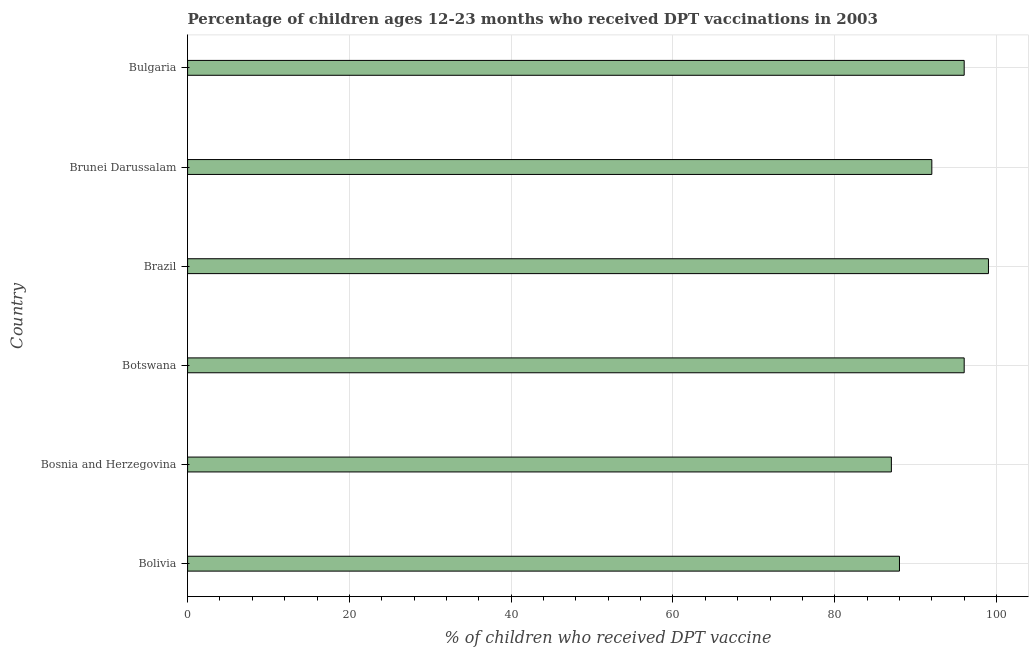What is the title of the graph?
Your answer should be very brief. Percentage of children ages 12-23 months who received DPT vaccinations in 2003. What is the label or title of the X-axis?
Ensure brevity in your answer.  % of children who received DPT vaccine. What is the percentage of children who received dpt vaccine in Botswana?
Your answer should be very brief. 96. In which country was the percentage of children who received dpt vaccine maximum?
Provide a succinct answer. Brazil. In which country was the percentage of children who received dpt vaccine minimum?
Give a very brief answer. Bosnia and Herzegovina. What is the sum of the percentage of children who received dpt vaccine?
Provide a succinct answer. 558. What is the difference between the percentage of children who received dpt vaccine in Bolivia and Botswana?
Keep it short and to the point. -8. What is the average percentage of children who received dpt vaccine per country?
Keep it short and to the point. 93. What is the median percentage of children who received dpt vaccine?
Ensure brevity in your answer.  94. What is the ratio of the percentage of children who received dpt vaccine in Bosnia and Herzegovina to that in Bulgaria?
Your answer should be compact. 0.91. Is the percentage of children who received dpt vaccine in Bolivia less than that in Brazil?
Offer a terse response. Yes. What is the difference between the highest and the second highest percentage of children who received dpt vaccine?
Offer a very short reply. 3. What is the difference between the highest and the lowest percentage of children who received dpt vaccine?
Make the answer very short. 12. In how many countries, is the percentage of children who received dpt vaccine greater than the average percentage of children who received dpt vaccine taken over all countries?
Keep it short and to the point. 3. Are all the bars in the graph horizontal?
Make the answer very short. Yes. How many countries are there in the graph?
Your response must be concise. 6. What is the % of children who received DPT vaccine in Botswana?
Keep it short and to the point. 96. What is the % of children who received DPT vaccine in Brazil?
Offer a terse response. 99. What is the % of children who received DPT vaccine in Brunei Darussalam?
Offer a terse response. 92. What is the % of children who received DPT vaccine of Bulgaria?
Offer a very short reply. 96. What is the difference between the % of children who received DPT vaccine in Bolivia and Bosnia and Herzegovina?
Your response must be concise. 1. What is the difference between the % of children who received DPT vaccine in Bolivia and Brazil?
Your response must be concise. -11. What is the difference between the % of children who received DPT vaccine in Bolivia and Brunei Darussalam?
Keep it short and to the point. -4. What is the difference between the % of children who received DPT vaccine in Bolivia and Bulgaria?
Make the answer very short. -8. What is the difference between the % of children who received DPT vaccine in Bosnia and Herzegovina and Botswana?
Offer a terse response. -9. What is the difference between the % of children who received DPT vaccine in Bosnia and Herzegovina and Brazil?
Ensure brevity in your answer.  -12. What is the difference between the % of children who received DPT vaccine in Bosnia and Herzegovina and Bulgaria?
Provide a succinct answer. -9. What is the difference between the % of children who received DPT vaccine in Botswana and Brazil?
Offer a terse response. -3. What is the difference between the % of children who received DPT vaccine in Botswana and Bulgaria?
Your answer should be compact. 0. What is the difference between the % of children who received DPT vaccine in Brazil and Brunei Darussalam?
Offer a terse response. 7. What is the difference between the % of children who received DPT vaccine in Brazil and Bulgaria?
Your response must be concise. 3. What is the ratio of the % of children who received DPT vaccine in Bolivia to that in Bosnia and Herzegovina?
Provide a short and direct response. 1.01. What is the ratio of the % of children who received DPT vaccine in Bolivia to that in Botswana?
Keep it short and to the point. 0.92. What is the ratio of the % of children who received DPT vaccine in Bolivia to that in Brazil?
Your answer should be very brief. 0.89. What is the ratio of the % of children who received DPT vaccine in Bolivia to that in Brunei Darussalam?
Offer a terse response. 0.96. What is the ratio of the % of children who received DPT vaccine in Bolivia to that in Bulgaria?
Offer a terse response. 0.92. What is the ratio of the % of children who received DPT vaccine in Bosnia and Herzegovina to that in Botswana?
Your answer should be very brief. 0.91. What is the ratio of the % of children who received DPT vaccine in Bosnia and Herzegovina to that in Brazil?
Offer a very short reply. 0.88. What is the ratio of the % of children who received DPT vaccine in Bosnia and Herzegovina to that in Brunei Darussalam?
Provide a succinct answer. 0.95. What is the ratio of the % of children who received DPT vaccine in Bosnia and Herzegovina to that in Bulgaria?
Give a very brief answer. 0.91. What is the ratio of the % of children who received DPT vaccine in Botswana to that in Brazil?
Your answer should be compact. 0.97. What is the ratio of the % of children who received DPT vaccine in Botswana to that in Brunei Darussalam?
Keep it short and to the point. 1.04. What is the ratio of the % of children who received DPT vaccine in Botswana to that in Bulgaria?
Keep it short and to the point. 1. What is the ratio of the % of children who received DPT vaccine in Brazil to that in Brunei Darussalam?
Your answer should be compact. 1.08. What is the ratio of the % of children who received DPT vaccine in Brazil to that in Bulgaria?
Your response must be concise. 1.03. What is the ratio of the % of children who received DPT vaccine in Brunei Darussalam to that in Bulgaria?
Provide a short and direct response. 0.96. 